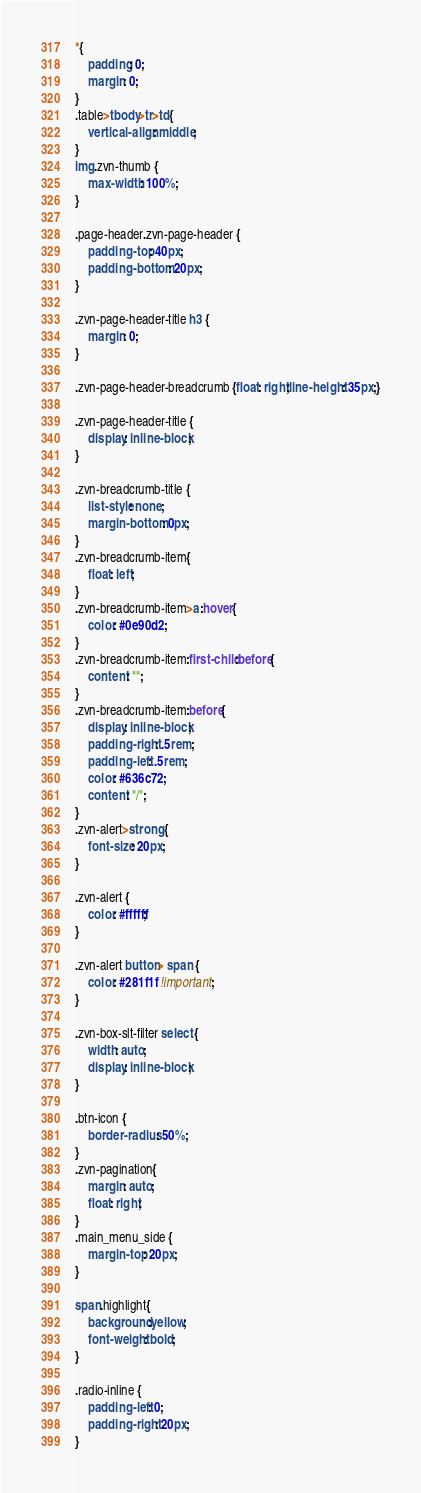<code> <loc_0><loc_0><loc_500><loc_500><_CSS_>*{
    padding: 0;
    margin: 0;
}
.table>tbody>tr>td{
    vertical-align: middle;
}
img.zvn-thumb {
    max-width: 100%;
}

.page-header.zvn-page-header {
    padding-top: 40px;
    padding-bottom: 20px;
}

.zvn-page-header-title h3 {
    margin: 0;
}

.zvn-page-header-breadcrumb {float: right;line-height: 35px;}

.zvn-page-header-title {
    display: inline-block;
}

.zvn-breadcrumb-title {
    list-style: none;
    margin-bottom: 0px;
}
.zvn-breadcrumb-item{
    float: left;
}
.zvn-breadcrumb-item>a:hover{
    color: #0e90d2;
}
.zvn-breadcrumb-item:first-child:before{
    content: "";
}
.zvn-breadcrumb-item:before{
    display: inline-block;
    padding-right: .5rem;
    padding-left: .5rem;
    color: #636c72;
    content: "/";
}
.zvn-alert>strong {
    font-size: 20px;
}

.zvn-alert {
    color: #ffffff;
}

.zvn-alert button> span {
    color: #281f1f !important;
}

.zvn-box-slt-filter select {
    width: auto;
    display: inline-block;
}

.btn-icon {
    border-radius: 50%;
}
.zvn-pagination{
    margin: auto;
    float: right;
}
.main_menu_side {
    margin-top: 20px;
}

span.highlight{
    background:yellow;
    font-weight: bold;
}

.radio-inline {
    padding-left: 0;
    padding-right: 20px;
}</code> 